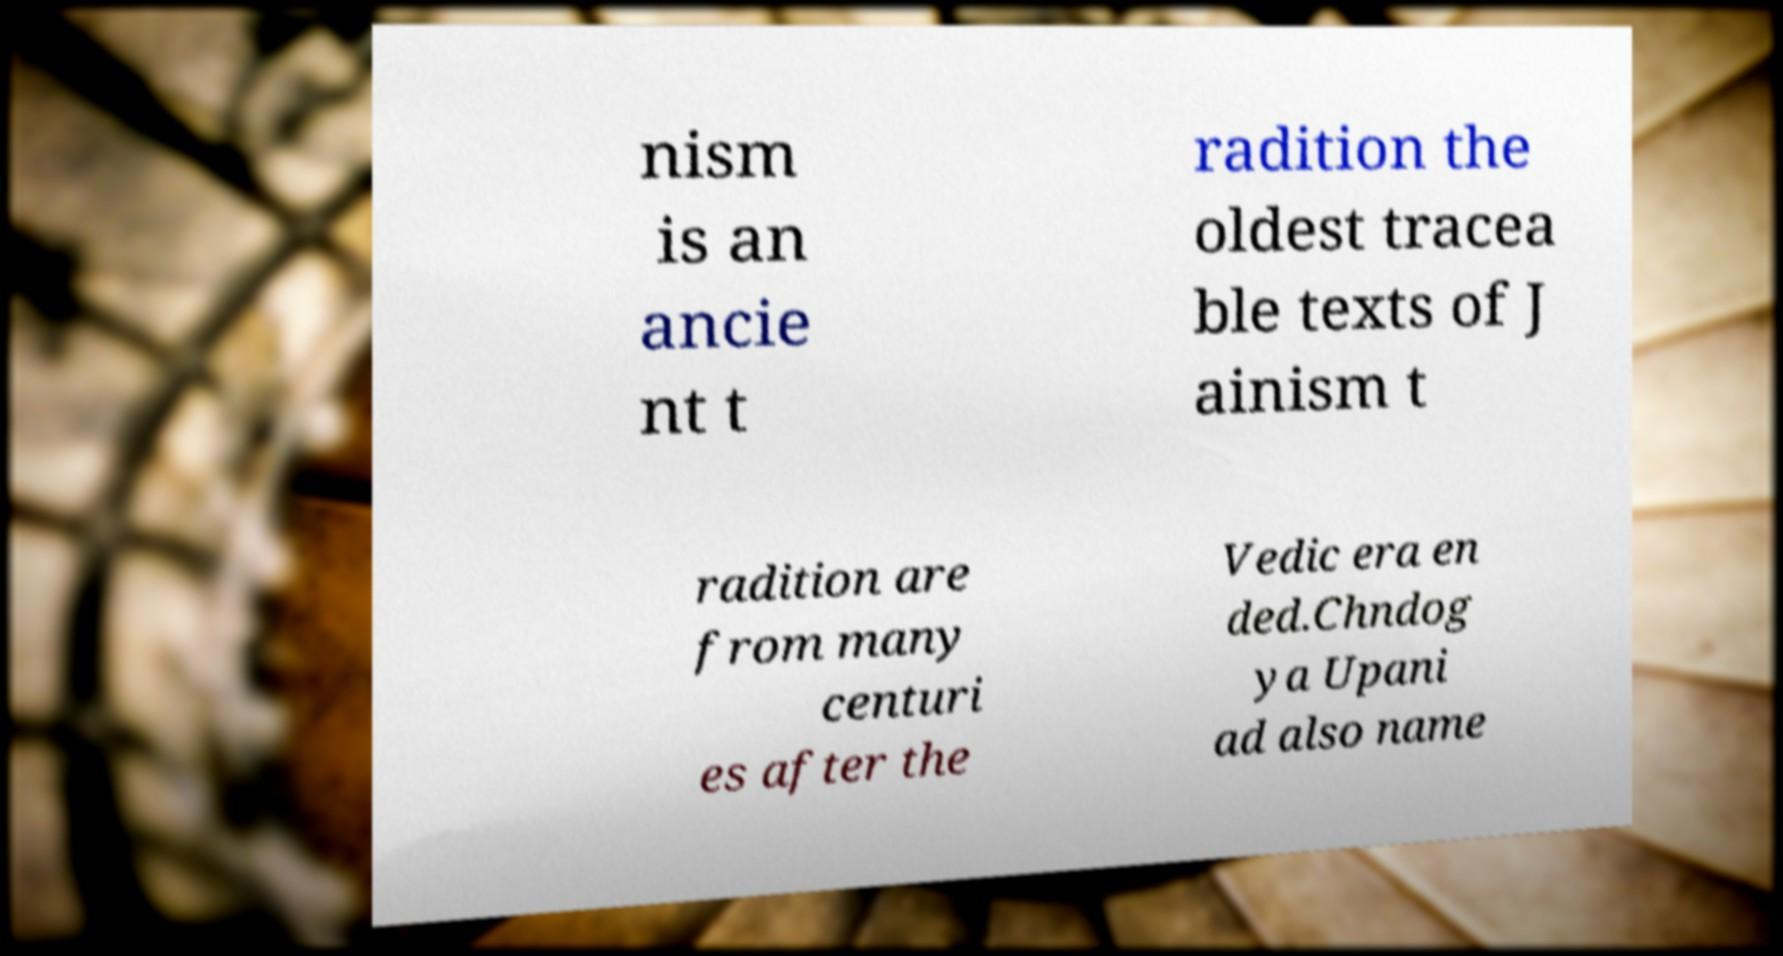I need the written content from this picture converted into text. Can you do that? nism is an ancie nt t radition the oldest tracea ble texts of J ainism t radition are from many centuri es after the Vedic era en ded.Chndog ya Upani ad also name 